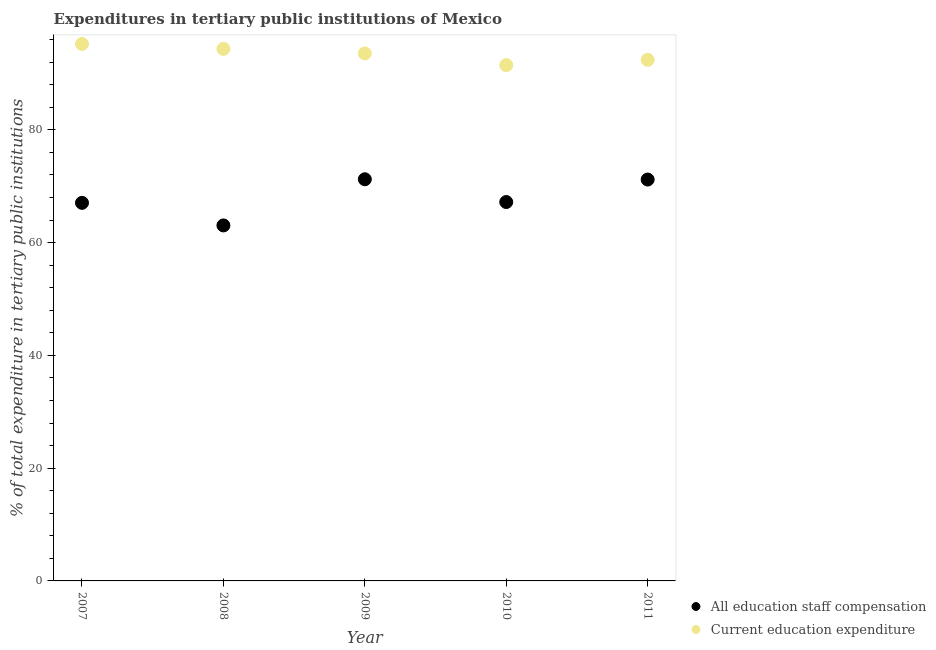How many different coloured dotlines are there?
Provide a succinct answer. 2. What is the expenditure in staff compensation in 2007?
Provide a succinct answer. 67.05. Across all years, what is the maximum expenditure in staff compensation?
Your answer should be compact. 71.23. Across all years, what is the minimum expenditure in education?
Provide a succinct answer. 91.48. What is the total expenditure in staff compensation in the graph?
Make the answer very short. 339.72. What is the difference between the expenditure in staff compensation in 2007 and that in 2009?
Offer a terse response. -4.18. What is the difference between the expenditure in education in 2007 and the expenditure in staff compensation in 2010?
Make the answer very short. 28.04. What is the average expenditure in staff compensation per year?
Your answer should be compact. 67.94. In the year 2008, what is the difference between the expenditure in staff compensation and expenditure in education?
Give a very brief answer. -31.31. What is the ratio of the expenditure in staff compensation in 2008 to that in 2010?
Your response must be concise. 0.94. What is the difference between the highest and the second highest expenditure in education?
Provide a succinct answer. 0.87. What is the difference between the highest and the lowest expenditure in staff compensation?
Offer a terse response. 8.18. Is the expenditure in staff compensation strictly greater than the expenditure in education over the years?
Make the answer very short. No. Are the values on the major ticks of Y-axis written in scientific E-notation?
Provide a short and direct response. No. Does the graph contain any zero values?
Provide a succinct answer. No. Does the graph contain grids?
Ensure brevity in your answer.  No. How many legend labels are there?
Keep it short and to the point. 2. What is the title of the graph?
Keep it short and to the point. Expenditures in tertiary public institutions of Mexico. Does "Primary school" appear as one of the legend labels in the graph?
Your answer should be compact. No. What is the label or title of the X-axis?
Your answer should be very brief. Year. What is the label or title of the Y-axis?
Give a very brief answer. % of total expenditure in tertiary public institutions. What is the % of total expenditure in tertiary public institutions in All education staff compensation in 2007?
Offer a very short reply. 67.05. What is the % of total expenditure in tertiary public institutions of Current education expenditure in 2007?
Provide a succinct answer. 95.23. What is the % of total expenditure in tertiary public institutions of All education staff compensation in 2008?
Provide a short and direct response. 63.05. What is the % of total expenditure in tertiary public institutions of Current education expenditure in 2008?
Provide a succinct answer. 94.36. What is the % of total expenditure in tertiary public institutions in All education staff compensation in 2009?
Provide a succinct answer. 71.23. What is the % of total expenditure in tertiary public institutions in Current education expenditure in 2009?
Offer a very short reply. 93.56. What is the % of total expenditure in tertiary public institutions in All education staff compensation in 2010?
Ensure brevity in your answer.  67.2. What is the % of total expenditure in tertiary public institutions in Current education expenditure in 2010?
Your answer should be very brief. 91.48. What is the % of total expenditure in tertiary public institutions in All education staff compensation in 2011?
Ensure brevity in your answer.  71.19. What is the % of total expenditure in tertiary public institutions of Current education expenditure in 2011?
Offer a terse response. 92.42. Across all years, what is the maximum % of total expenditure in tertiary public institutions of All education staff compensation?
Your answer should be compact. 71.23. Across all years, what is the maximum % of total expenditure in tertiary public institutions of Current education expenditure?
Your response must be concise. 95.23. Across all years, what is the minimum % of total expenditure in tertiary public institutions of All education staff compensation?
Your answer should be very brief. 63.05. Across all years, what is the minimum % of total expenditure in tertiary public institutions in Current education expenditure?
Offer a very short reply. 91.48. What is the total % of total expenditure in tertiary public institutions in All education staff compensation in the graph?
Make the answer very short. 339.72. What is the total % of total expenditure in tertiary public institutions of Current education expenditure in the graph?
Offer a terse response. 467.06. What is the difference between the % of total expenditure in tertiary public institutions in All education staff compensation in 2007 and that in 2008?
Ensure brevity in your answer.  4. What is the difference between the % of total expenditure in tertiary public institutions of Current education expenditure in 2007 and that in 2008?
Give a very brief answer. 0.87. What is the difference between the % of total expenditure in tertiary public institutions in All education staff compensation in 2007 and that in 2009?
Give a very brief answer. -4.18. What is the difference between the % of total expenditure in tertiary public institutions in Current education expenditure in 2007 and that in 2009?
Give a very brief answer. 1.67. What is the difference between the % of total expenditure in tertiary public institutions in All education staff compensation in 2007 and that in 2010?
Provide a short and direct response. -0.15. What is the difference between the % of total expenditure in tertiary public institutions of Current education expenditure in 2007 and that in 2010?
Ensure brevity in your answer.  3.76. What is the difference between the % of total expenditure in tertiary public institutions of All education staff compensation in 2007 and that in 2011?
Offer a terse response. -4.13. What is the difference between the % of total expenditure in tertiary public institutions in Current education expenditure in 2007 and that in 2011?
Provide a short and direct response. 2.81. What is the difference between the % of total expenditure in tertiary public institutions in All education staff compensation in 2008 and that in 2009?
Keep it short and to the point. -8.18. What is the difference between the % of total expenditure in tertiary public institutions in Current education expenditure in 2008 and that in 2009?
Your answer should be very brief. 0.8. What is the difference between the % of total expenditure in tertiary public institutions of All education staff compensation in 2008 and that in 2010?
Ensure brevity in your answer.  -4.15. What is the difference between the % of total expenditure in tertiary public institutions of Current education expenditure in 2008 and that in 2010?
Your answer should be very brief. 2.89. What is the difference between the % of total expenditure in tertiary public institutions of All education staff compensation in 2008 and that in 2011?
Keep it short and to the point. -8.14. What is the difference between the % of total expenditure in tertiary public institutions in Current education expenditure in 2008 and that in 2011?
Offer a terse response. 1.94. What is the difference between the % of total expenditure in tertiary public institutions of All education staff compensation in 2009 and that in 2010?
Your answer should be very brief. 4.04. What is the difference between the % of total expenditure in tertiary public institutions of Current education expenditure in 2009 and that in 2010?
Your response must be concise. 2.09. What is the difference between the % of total expenditure in tertiary public institutions of All education staff compensation in 2009 and that in 2011?
Offer a very short reply. 0.05. What is the difference between the % of total expenditure in tertiary public institutions in Current education expenditure in 2009 and that in 2011?
Your answer should be compact. 1.14. What is the difference between the % of total expenditure in tertiary public institutions in All education staff compensation in 2010 and that in 2011?
Ensure brevity in your answer.  -3.99. What is the difference between the % of total expenditure in tertiary public institutions of Current education expenditure in 2010 and that in 2011?
Your answer should be compact. -0.95. What is the difference between the % of total expenditure in tertiary public institutions of All education staff compensation in 2007 and the % of total expenditure in tertiary public institutions of Current education expenditure in 2008?
Ensure brevity in your answer.  -27.31. What is the difference between the % of total expenditure in tertiary public institutions in All education staff compensation in 2007 and the % of total expenditure in tertiary public institutions in Current education expenditure in 2009?
Provide a succinct answer. -26.51. What is the difference between the % of total expenditure in tertiary public institutions in All education staff compensation in 2007 and the % of total expenditure in tertiary public institutions in Current education expenditure in 2010?
Your response must be concise. -24.43. What is the difference between the % of total expenditure in tertiary public institutions of All education staff compensation in 2007 and the % of total expenditure in tertiary public institutions of Current education expenditure in 2011?
Offer a very short reply. -25.37. What is the difference between the % of total expenditure in tertiary public institutions in All education staff compensation in 2008 and the % of total expenditure in tertiary public institutions in Current education expenditure in 2009?
Give a very brief answer. -30.51. What is the difference between the % of total expenditure in tertiary public institutions of All education staff compensation in 2008 and the % of total expenditure in tertiary public institutions of Current education expenditure in 2010?
Offer a very short reply. -28.43. What is the difference between the % of total expenditure in tertiary public institutions in All education staff compensation in 2008 and the % of total expenditure in tertiary public institutions in Current education expenditure in 2011?
Your answer should be compact. -29.37. What is the difference between the % of total expenditure in tertiary public institutions in All education staff compensation in 2009 and the % of total expenditure in tertiary public institutions in Current education expenditure in 2010?
Your response must be concise. -20.24. What is the difference between the % of total expenditure in tertiary public institutions of All education staff compensation in 2009 and the % of total expenditure in tertiary public institutions of Current education expenditure in 2011?
Offer a very short reply. -21.19. What is the difference between the % of total expenditure in tertiary public institutions of All education staff compensation in 2010 and the % of total expenditure in tertiary public institutions of Current education expenditure in 2011?
Offer a terse response. -25.22. What is the average % of total expenditure in tertiary public institutions of All education staff compensation per year?
Ensure brevity in your answer.  67.94. What is the average % of total expenditure in tertiary public institutions of Current education expenditure per year?
Provide a succinct answer. 93.41. In the year 2007, what is the difference between the % of total expenditure in tertiary public institutions in All education staff compensation and % of total expenditure in tertiary public institutions in Current education expenditure?
Give a very brief answer. -28.18. In the year 2008, what is the difference between the % of total expenditure in tertiary public institutions of All education staff compensation and % of total expenditure in tertiary public institutions of Current education expenditure?
Provide a succinct answer. -31.31. In the year 2009, what is the difference between the % of total expenditure in tertiary public institutions of All education staff compensation and % of total expenditure in tertiary public institutions of Current education expenditure?
Offer a terse response. -22.33. In the year 2010, what is the difference between the % of total expenditure in tertiary public institutions in All education staff compensation and % of total expenditure in tertiary public institutions in Current education expenditure?
Ensure brevity in your answer.  -24.28. In the year 2011, what is the difference between the % of total expenditure in tertiary public institutions of All education staff compensation and % of total expenditure in tertiary public institutions of Current education expenditure?
Provide a succinct answer. -21.24. What is the ratio of the % of total expenditure in tertiary public institutions of All education staff compensation in 2007 to that in 2008?
Provide a succinct answer. 1.06. What is the ratio of the % of total expenditure in tertiary public institutions of Current education expenditure in 2007 to that in 2008?
Your answer should be compact. 1.01. What is the ratio of the % of total expenditure in tertiary public institutions in All education staff compensation in 2007 to that in 2009?
Make the answer very short. 0.94. What is the ratio of the % of total expenditure in tertiary public institutions of Current education expenditure in 2007 to that in 2009?
Make the answer very short. 1.02. What is the ratio of the % of total expenditure in tertiary public institutions in All education staff compensation in 2007 to that in 2010?
Ensure brevity in your answer.  1. What is the ratio of the % of total expenditure in tertiary public institutions of Current education expenditure in 2007 to that in 2010?
Provide a short and direct response. 1.04. What is the ratio of the % of total expenditure in tertiary public institutions in All education staff compensation in 2007 to that in 2011?
Your answer should be compact. 0.94. What is the ratio of the % of total expenditure in tertiary public institutions of Current education expenditure in 2007 to that in 2011?
Give a very brief answer. 1.03. What is the ratio of the % of total expenditure in tertiary public institutions of All education staff compensation in 2008 to that in 2009?
Your response must be concise. 0.89. What is the ratio of the % of total expenditure in tertiary public institutions in Current education expenditure in 2008 to that in 2009?
Ensure brevity in your answer.  1.01. What is the ratio of the % of total expenditure in tertiary public institutions in All education staff compensation in 2008 to that in 2010?
Give a very brief answer. 0.94. What is the ratio of the % of total expenditure in tertiary public institutions of Current education expenditure in 2008 to that in 2010?
Your answer should be very brief. 1.03. What is the ratio of the % of total expenditure in tertiary public institutions in All education staff compensation in 2008 to that in 2011?
Make the answer very short. 0.89. What is the ratio of the % of total expenditure in tertiary public institutions in All education staff compensation in 2009 to that in 2010?
Provide a succinct answer. 1.06. What is the ratio of the % of total expenditure in tertiary public institutions of Current education expenditure in 2009 to that in 2010?
Offer a very short reply. 1.02. What is the ratio of the % of total expenditure in tertiary public institutions in All education staff compensation in 2009 to that in 2011?
Your answer should be compact. 1. What is the ratio of the % of total expenditure in tertiary public institutions of Current education expenditure in 2009 to that in 2011?
Provide a short and direct response. 1.01. What is the ratio of the % of total expenditure in tertiary public institutions of All education staff compensation in 2010 to that in 2011?
Offer a very short reply. 0.94. What is the difference between the highest and the second highest % of total expenditure in tertiary public institutions in All education staff compensation?
Ensure brevity in your answer.  0.05. What is the difference between the highest and the second highest % of total expenditure in tertiary public institutions of Current education expenditure?
Provide a succinct answer. 0.87. What is the difference between the highest and the lowest % of total expenditure in tertiary public institutions of All education staff compensation?
Offer a terse response. 8.18. What is the difference between the highest and the lowest % of total expenditure in tertiary public institutions in Current education expenditure?
Offer a very short reply. 3.76. 